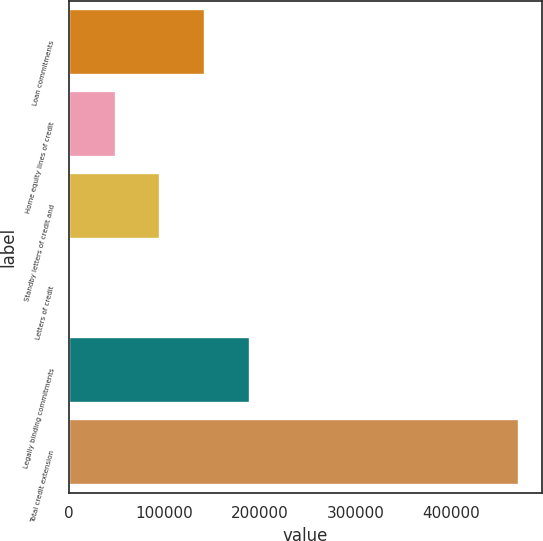<chart> <loc_0><loc_0><loc_500><loc_500><bar_chart><fcel>Loan commitments<fcel>Home equity lines of credit<fcel>Standby letters of credit and<fcel>Letters of credit<fcel>Legally binding commitments<fcel>Total credit extension<nl><fcel>142714<fcel>48826.7<fcel>95770.4<fcel>1883<fcel>189658<fcel>471320<nl></chart> 